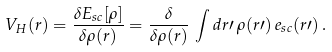<formula> <loc_0><loc_0><loc_500><loc_500>V _ { H } ( { r } ) = \frac { \delta E _ { s c } [ \rho ] } { \delta \rho ( { r } ) } = \frac { \delta } { \delta \rho ( { r } ) } \, \int d { r } \prime \, \rho ( { r } \prime ) \, e _ { s c } ( { r } \prime ) \, .</formula> 